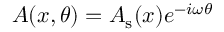<formula> <loc_0><loc_0><loc_500><loc_500>A ( x , \theta ) = A _ { s } ( x ) e ^ { - i \omega \theta }</formula> 